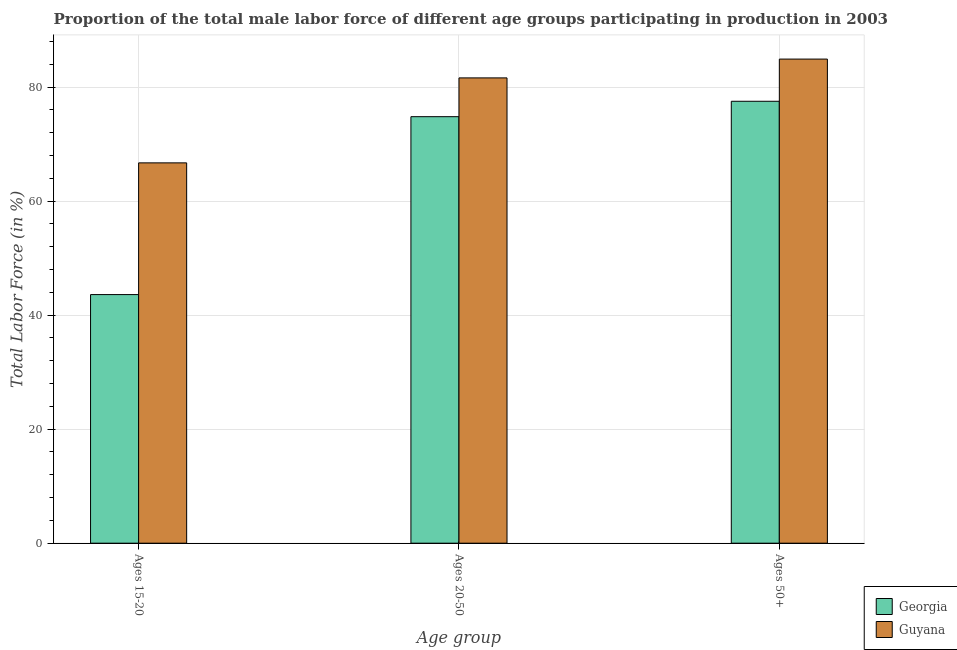How many different coloured bars are there?
Your answer should be compact. 2. How many groups of bars are there?
Offer a very short reply. 3. What is the label of the 2nd group of bars from the left?
Your response must be concise. Ages 20-50. What is the percentage of male labor force within the age group 20-50 in Guyana?
Keep it short and to the point. 81.6. Across all countries, what is the maximum percentage of male labor force above age 50?
Ensure brevity in your answer.  84.9. Across all countries, what is the minimum percentage of male labor force within the age group 15-20?
Keep it short and to the point. 43.6. In which country was the percentage of male labor force within the age group 20-50 maximum?
Make the answer very short. Guyana. In which country was the percentage of male labor force above age 50 minimum?
Offer a terse response. Georgia. What is the total percentage of male labor force within the age group 15-20 in the graph?
Make the answer very short. 110.3. What is the difference between the percentage of male labor force above age 50 in Guyana and that in Georgia?
Offer a terse response. 7.4. What is the difference between the percentage of male labor force within the age group 20-50 in Guyana and the percentage of male labor force within the age group 15-20 in Georgia?
Your answer should be compact. 38. What is the average percentage of male labor force above age 50 per country?
Offer a very short reply. 81.2. What is the difference between the percentage of male labor force above age 50 and percentage of male labor force within the age group 15-20 in Georgia?
Ensure brevity in your answer.  33.9. In how many countries, is the percentage of male labor force above age 50 greater than 12 %?
Your response must be concise. 2. What is the ratio of the percentage of male labor force above age 50 in Guyana to that in Georgia?
Your response must be concise. 1.1. Is the difference between the percentage of male labor force above age 50 in Georgia and Guyana greater than the difference between the percentage of male labor force within the age group 15-20 in Georgia and Guyana?
Offer a terse response. Yes. What is the difference between the highest and the second highest percentage of male labor force above age 50?
Your response must be concise. 7.4. What is the difference between the highest and the lowest percentage of male labor force within the age group 20-50?
Your response must be concise. 6.8. In how many countries, is the percentage of male labor force within the age group 20-50 greater than the average percentage of male labor force within the age group 20-50 taken over all countries?
Your answer should be compact. 1. What does the 2nd bar from the left in Ages 15-20 represents?
Your answer should be compact. Guyana. What does the 2nd bar from the right in Ages 15-20 represents?
Provide a succinct answer. Georgia. Is it the case that in every country, the sum of the percentage of male labor force within the age group 15-20 and percentage of male labor force within the age group 20-50 is greater than the percentage of male labor force above age 50?
Your answer should be very brief. Yes. How many bars are there?
Offer a very short reply. 6. What is the difference between two consecutive major ticks on the Y-axis?
Give a very brief answer. 20. Does the graph contain any zero values?
Your answer should be very brief. No. Does the graph contain grids?
Your response must be concise. Yes. Where does the legend appear in the graph?
Keep it short and to the point. Bottom right. How many legend labels are there?
Make the answer very short. 2. How are the legend labels stacked?
Offer a terse response. Vertical. What is the title of the graph?
Give a very brief answer. Proportion of the total male labor force of different age groups participating in production in 2003. What is the label or title of the X-axis?
Provide a succinct answer. Age group. What is the label or title of the Y-axis?
Give a very brief answer. Total Labor Force (in %). What is the Total Labor Force (in %) in Georgia in Ages 15-20?
Your response must be concise. 43.6. What is the Total Labor Force (in %) of Guyana in Ages 15-20?
Your answer should be compact. 66.7. What is the Total Labor Force (in %) in Georgia in Ages 20-50?
Your answer should be very brief. 74.8. What is the Total Labor Force (in %) in Guyana in Ages 20-50?
Provide a short and direct response. 81.6. What is the Total Labor Force (in %) of Georgia in Ages 50+?
Ensure brevity in your answer.  77.5. What is the Total Labor Force (in %) of Guyana in Ages 50+?
Ensure brevity in your answer.  84.9. Across all Age group, what is the maximum Total Labor Force (in %) in Georgia?
Your response must be concise. 77.5. Across all Age group, what is the maximum Total Labor Force (in %) in Guyana?
Provide a succinct answer. 84.9. Across all Age group, what is the minimum Total Labor Force (in %) of Georgia?
Provide a short and direct response. 43.6. Across all Age group, what is the minimum Total Labor Force (in %) of Guyana?
Make the answer very short. 66.7. What is the total Total Labor Force (in %) of Georgia in the graph?
Make the answer very short. 195.9. What is the total Total Labor Force (in %) in Guyana in the graph?
Keep it short and to the point. 233.2. What is the difference between the Total Labor Force (in %) of Georgia in Ages 15-20 and that in Ages 20-50?
Provide a succinct answer. -31.2. What is the difference between the Total Labor Force (in %) in Guyana in Ages 15-20 and that in Ages 20-50?
Offer a terse response. -14.9. What is the difference between the Total Labor Force (in %) of Georgia in Ages 15-20 and that in Ages 50+?
Provide a short and direct response. -33.9. What is the difference between the Total Labor Force (in %) of Guyana in Ages 15-20 and that in Ages 50+?
Give a very brief answer. -18.2. What is the difference between the Total Labor Force (in %) in Georgia in Ages 20-50 and that in Ages 50+?
Keep it short and to the point. -2.7. What is the difference between the Total Labor Force (in %) in Guyana in Ages 20-50 and that in Ages 50+?
Offer a terse response. -3.3. What is the difference between the Total Labor Force (in %) of Georgia in Ages 15-20 and the Total Labor Force (in %) of Guyana in Ages 20-50?
Offer a terse response. -38. What is the difference between the Total Labor Force (in %) in Georgia in Ages 15-20 and the Total Labor Force (in %) in Guyana in Ages 50+?
Offer a very short reply. -41.3. What is the average Total Labor Force (in %) in Georgia per Age group?
Your response must be concise. 65.3. What is the average Total Labor Force (in %) in Guyana per Age group?
Provide a succinct answer. 77.73. What is the difference between the Total Labor Force (in %) of Georgia and Total Labor Force (in %) of Guyana in Ages 15-20?
Ensure brevity in your answer.  -23.1. What is the ratio of the Total Labor Force (in %) of Georgia in Ages 15-20 to that in Ages 20-50?
Your response must be concise. 0.58. What is the ratio of the Total Labor Force (in %) in Guyana in Ages 15-20 to that in Ages 20-50?
Your answer should be compact. 0.82. What is the ratio of the Total Labor Force (in %) in Georgia in Ages 15-20 to that in Ages 50+?
Make the answer very short. 0.56. What is the ratio of the Total Labor Force (in %) in Guyana in Ages 15-20 to that in Ages 50+?
Provide a succinct answer. 0.79. What is the ratio of the Total Labor Force (in %) of Georgia in Ages 20-50 to that in Ages 50+?
Your response must be concise. 0.97. What is the ratio of the Total Labor Force (in %) in Guyana in Ages 20-50 to that in Ages 50+?
Provide a short and direct response. 0.96. What is the difference between the highest and the lowest Total Labor Force (in %) in Georgia?
Keep it short and to the point. 33.9. What is the difference between the highest and the lowest Total Labor Force (in %) in Guyana?
Make the answer very short. 18.2. 